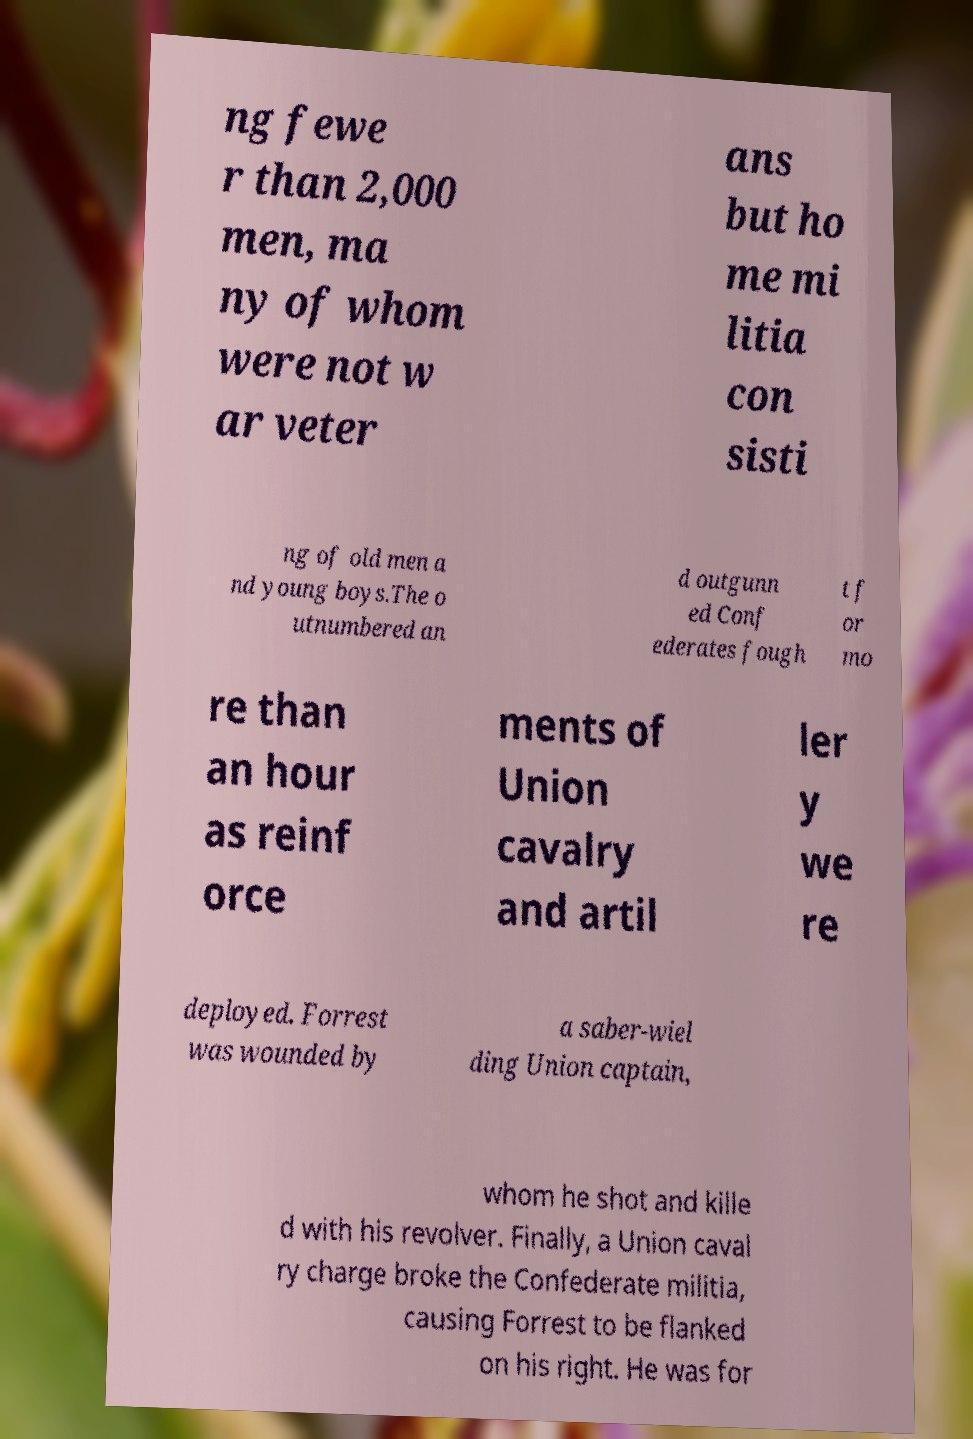Please identify and transcribe the text found in this image. ng fewe r than 2,000 men, ma ny of whom were not w ar veter ans but ho me mi litia con sisti ng of old men a nd young boys.The o utnumbered an d outgunn ed Conf ederates fough t f or mo re than an hour as reinf orce ments of Union cavalry and artil ler y we re deployed. Forrest was wounded by a saber-wiel ding Union captain, whom he shot and kille d with his revolver. Finally, a Union caval ry charge broke the Confederate militia, causing Forrest to be flanked on his right. He was for 